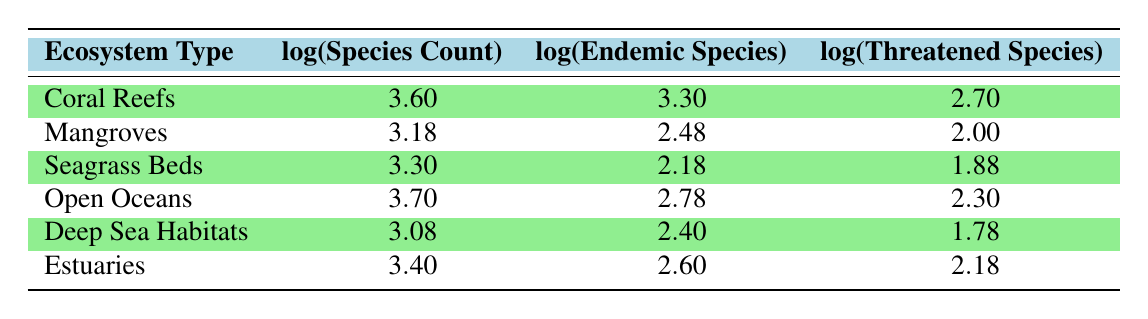What is the log(Species Count) for Coral Reefs? From the table, the log(Species Count) for Coral Reefs is directly listed under the corresponding column, which shows a value of 3.60.
Answer: 3.60 How many Endemic Species are found in Open Oceans? The table indicates that Open Oceans has an Endemic Species Count of 600, which corresponds to the log value of 2.78.
Answer: 600 What is the total log(Threatened Species) for Mangroves and Seagrass Beds combined? We sum the log(Threatened Species) values for both Mangroves (2.00) and Seagrass Beds (1.88) to get a total of 2.00 + 1.88 = 3.88.
Answer: 3.88 Which ecosystem type has the highest log(Endemic Species)? By examining the log(Endemic Species) values, Coral Reefs has a value of 3.30, which is the highest among all ecosystem types compared in the table.
Answer: Coral Reefs Is the log(Species Count) for Estuaries greater than that for Deep Sea Habitats? The log(Species Count) for Estuaries is 3.40, while for Deep Sea Habitats it is 3.08. Since 3.40 is greater than 3.08, the answer is yes.
Answer: Yes Which ecosystem has the fewest log(Threatened Species)? Checking the log(Threatened Species) values, Deep Sea Habitats has a value of 1.78, which is the lowest compared to other ecosystem types in the table.
Answer: Deep Sea Habitats What is the average log(Species Count) across all ecosystem types? To find the average, we first sum the log(Species Count) values: 3.60 + 3.18 + 3.30 + 3.70 + 3.08 + 3.40 = 20.26. Then we divide by the number of ecosystem types, which is 6: 20.26 / 6 = 3.38.
Answer: 3.38 Are there more than 200 Endemic Species in Seagrass Beds? The log(Endemic Species) for Seagrass Beds is 2.18, which corresponds to approximately 150 species. Since 150 is less than 200, the answer is no.
Answer: No What is the difference in log(Species Count) between Open Oceans and Coral Reefs? By subtracting the log(Species Count) of Coral Reefs (3.60) from that of Open Oceans (3.70), we find the difference of 3.70 - 3.60 = 0.10.
Answer: 0.10 